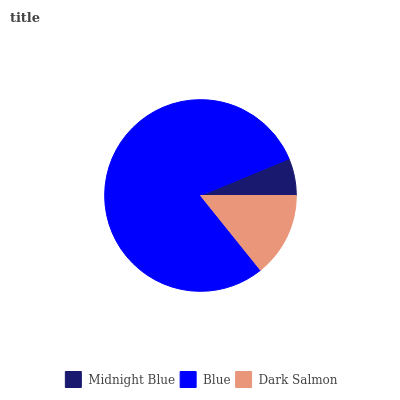Is Midnight Blue the minimum?
Answer yes or no. Yes. Is Blue the maximum?
Answer yes or no. Yes. Is Dark Salmon the minimum?
Answer yes or no. No. Is Dark Salmon the maximum?
Answer yes or no. No. Is Blue greater than Dark Salmon?
Answer yes or no. Yes. Is Dark Salmon less than Blue?
Answer yes or no. Yes. Is Dark Salmon greater than Blue?
Answer yes or no. No. Is Blue less than Dark Salmon?
Answer yes or no. No. Is Dark Salmon the high median?
Answer yes or no. Yes. Is Dark Salmon the low median?
Answer yes or no. Yes. Is Blue the high median?
Answer yes or no. No. Is Midnight Blue the low median?
Answer yes or no. No. 